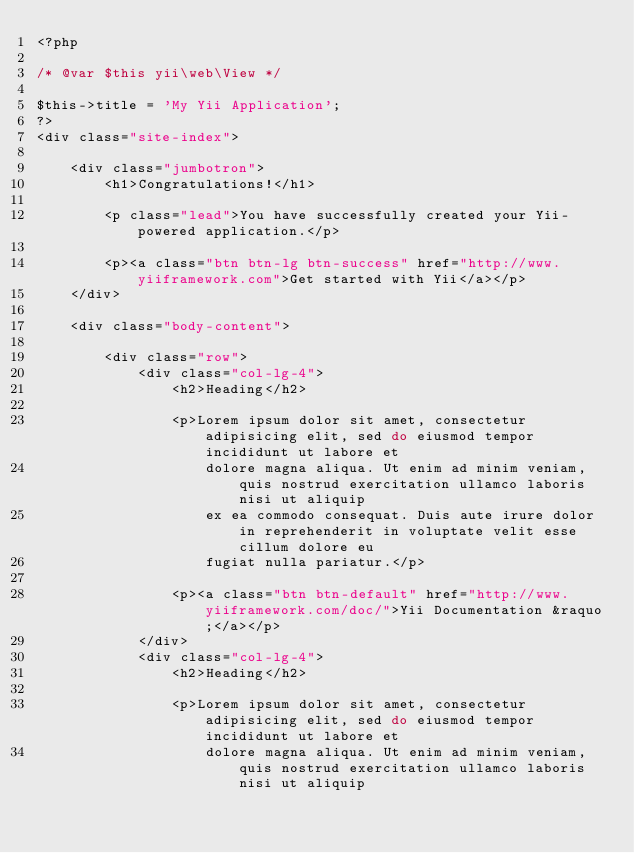<code> <loc_0><loc_0><loc_500><loc_500><_PHP_><?php

/* @var $this yii\web\View */

$this->title = 'My Yii Application';
?>
<div class="site-index">

    <div class="jumbotron">
        <h1>Congratulations!</h1>

        <p class="lead">You have successfully created your Yii-powered application.</p>

        <p><a class="btn btn-lg btn-success" href="http://www.yiiframework.com">Get started with Yii</a></p>
    </div>

    <div class="body-content">

        <div class="row">
            <div class="col-lg-4">
                <h2>Heading</h2>

                <p>Lorem ipsum dolor sit amet, consectetur adipisicing elit, sed do eiusmod tempor incididunt ut labore et
                    dolore magna aliqua. Ut enim ad minim veniam, quis nostrud exercitation ullamco laboris nisi ut aliquip
                    ex ea commodo consequat. Duis aute irure dolor in reprehenderit in voluptate velit esse cillum dolore eu
                    fugiat nulla pariatur.</p>

                <p><a class="btn btn-default" href="http://www.yiiframework.com/doc/">Yii Documentation &raquo;</a></p>
            </div>
            <div class="col-lg-4">
                <h2>Heading</h2>

                <p>Lorem ipsum dolor sit amet, consectetur adipisicing elit, sed do eiusmod tempor incididunt ut labore et
                    dolore magna aliqua. Ut enim ad minim veniam, quis nostrud exercitation ullamco laboris nisi ut aliquip</code> 